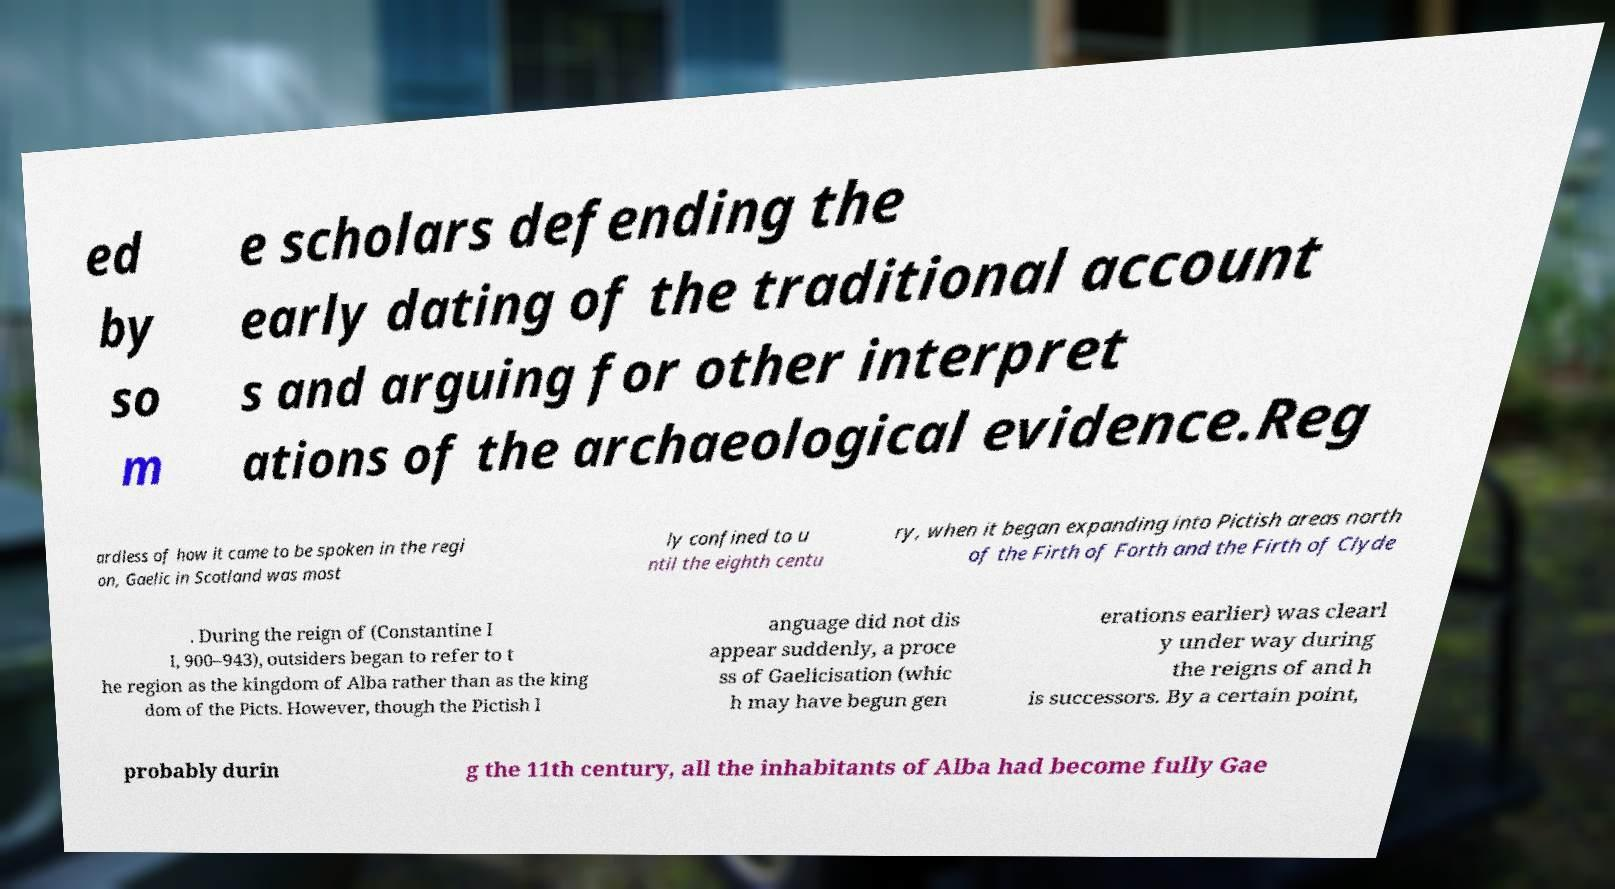I need the written content from this picture converted into text. Can you do that? ed by so m e scholars defending the early dating of the traditional account s and arguing for other interpret ations of the archaeological evidence.Reg ardless of how it came to be spoken in the regi on, Gaelic in Scotland was most ly confined to u ntil the eighth centu ry, when it began expanding into Pictish areas north of the Firth of Forth and the Firth of Clyde . During the reign of (Constantine I I, 900–943), outsiders began to refer to t he region as the kingdom of Alba rather than as the king dom of the Picts. However, though the Pictish l anguage did not dis appear suddenly, a proce ss of Gaelicisation (whic h may have begun gen erations earlier) was clearl y under way during the reigns of and h is successors. By a certain point, probably durin g the 11th century, all the inhabitants of Alba had become fully Gae 